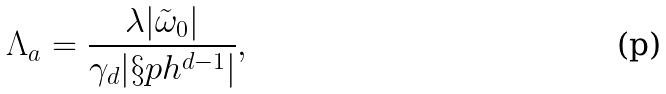<formula> <loc_0><loc_0><loc_500><loc_500>\Lambda _ { a } = \frac { \lambda | { \tilde { \omega } } _ { 0 } | } { \gamma _ { d } | \S p h ^ { d - 1 } | } ,</formula> 